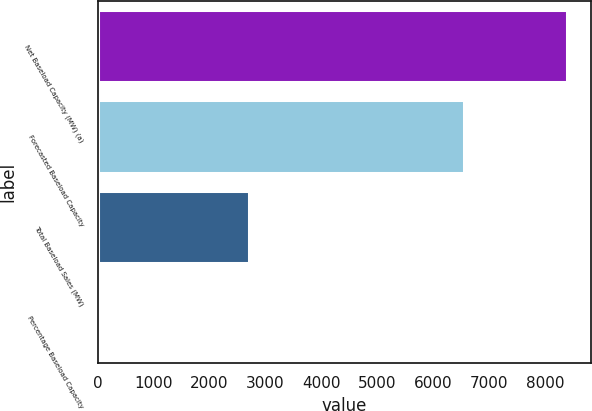Convert chart to OTSL. <chart><loc_0><loc_0><loc_500><loc_500><bar_chart><fcel>Net Baseload Capacity (MW) (a)<fcel>Forecasted Baseload Capacity<fcel>Total Baseload Sales (MW)<fcel>Percentage Baseload Capacity<nl><fcel>8393<fcel>6545<fcel>2697<fcel>41<nl></chart> 